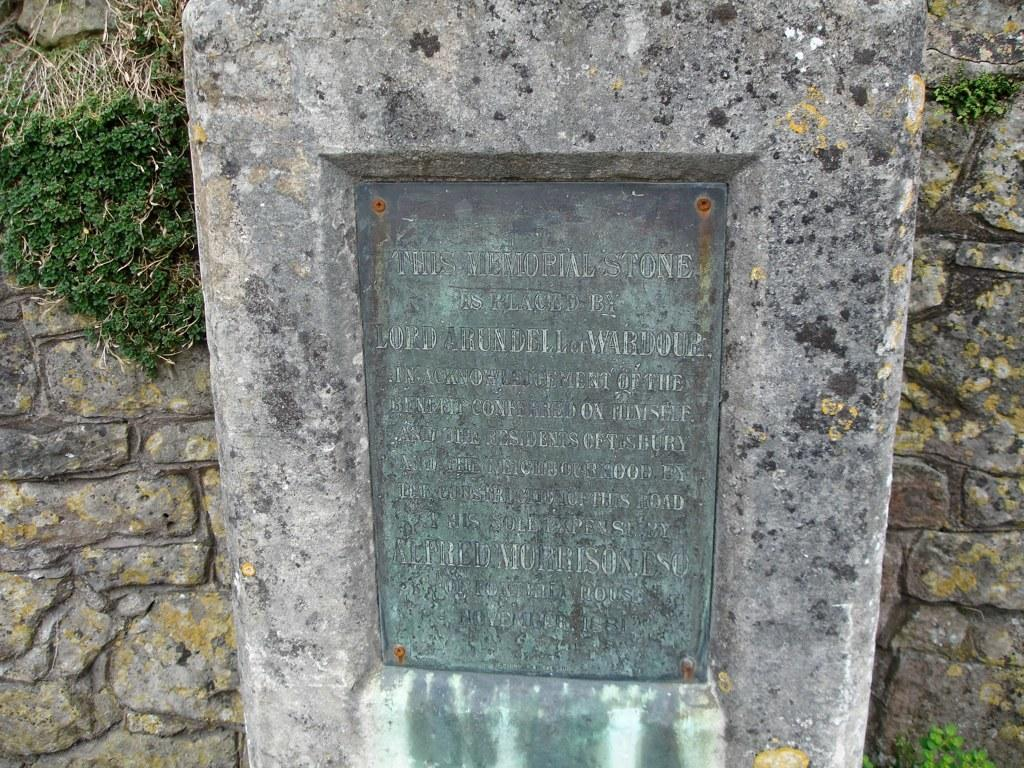What is written on in the image? There is writing on a stone in the image. What type of vegetation can be seen in the image? There are plants visible in the image. What kind of structure is present in the image? There is a rock wall in the image. What type of butter is being spread on the rock wall in the image? There is no butter present in the image; it features writing on a stone, plants, and a rock wall. 